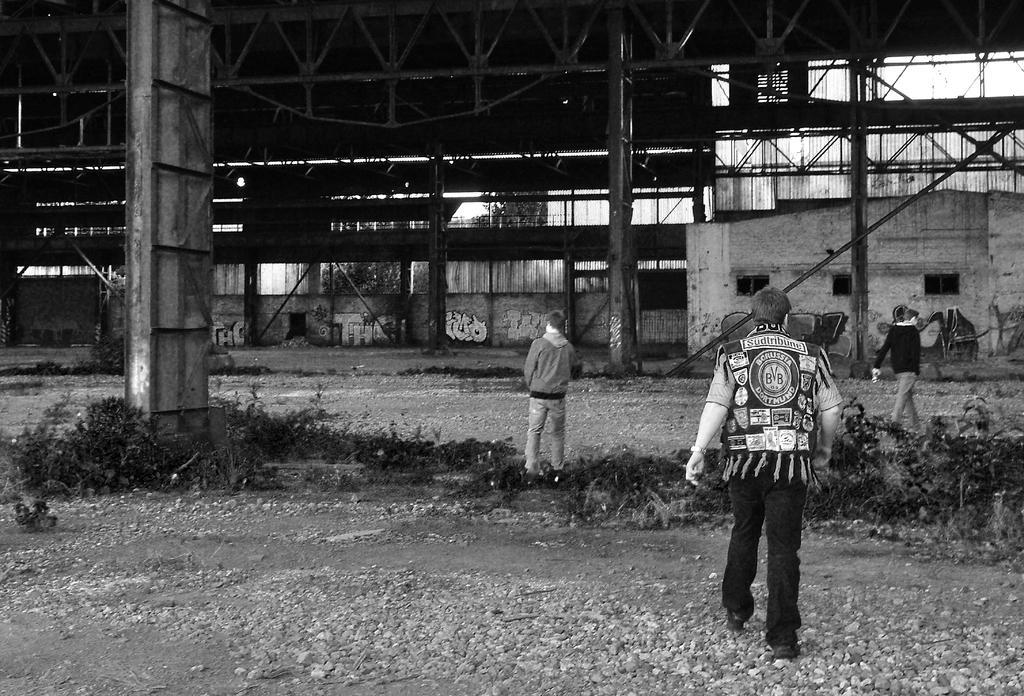In one or two sentences, can you explain what this image depicts? This is a black and white image where we can see people on the land. In the background, we can see the wall and pillars. At the top of the image, we can see the roof. We can see some plants on the land. 